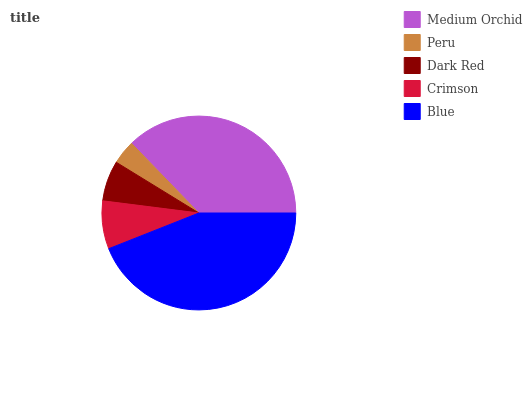Is Peru the minimum?
Answer yes or no. Yes. Is Blue the maximum?
Answer yes or no. Yes. Is Dark Red the minimum?
Answer yes or no. No. Is Dark Red the maximum?
Answer yes or no. No. Is Dark Red greater than Peru?
Answer yes or no. Yes. Is Peru less than Dark Red?
Answer yes or no. Yes. Is Peru greater than Dark Red?
Answer yes or no. No. Is Dark Red less than Peru?
Answer yes or no. No. Is Crimson the high median?
Answer yes or no. Yes. Is Crimson the low median?
Answer yes or no. Yes. Is Dark Red the high median?
Answer yes or no. No. Is Peru the low median?
Answer yes or no. No. 